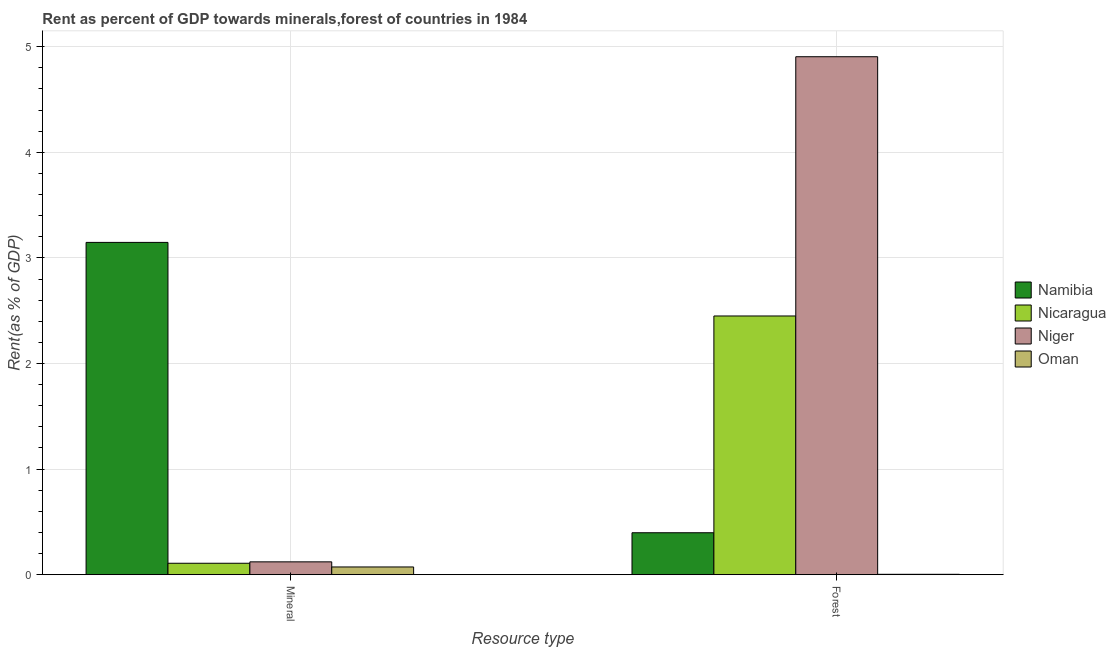How many groups of bars are there?
Offer a terse response. 2. How many bars are there on the 2nd tick from the left?
Offer a very short reply. 4. What is the label of the 2nd group of bars from the left?
Your answer should be very brief. Forest. What is the mineral rent in Namibia?
Your answer should be compact. 3.15. Across all countries, what is the maximum forest rent?
Offer a very short reply. 4.9. Across all countries, what is the minimum mineral rent?
Give a very brief answer. 0.07. In which country was the mineral rent maximum?
Provide a short and direct response. Namibia. In which country was the forest rent minimum?
Your answer should be very brief. Oman. What is the total forest rent in the graph?
Offer a very short reply. 7.76. What is the difference between the mineral rent in Oman and that in Nicaragua?
Provide a short and direct response. -0.04. What is the difference between the mineral rent in Niger and the forest rent in Namibia?
Offer a very short reply. -0.28. What is the average forest rent per country?
Offer a terse response. 1.94. What is the difference between the mineral rent and forest rent in Namibia?
Your answer should be compact. 2.75. What is the ratio of the mineral rent in Nicaragua to that in Niger?
Give a very brief answer. 0.89. Is the mineral rent in Nicaragua less than that in Oman?
Ensure brevity in your answer.  No. In how many countries, is the forest rent greater than the average forest rent taken over all countries?
Your answer should be compact. 2. What does the 3rd bar from the left in Mineral represents?
Give a very brief answer. Niger. What does the 3rd bar from the right in Forest represents?
Provide a succinct answer. Nicaragua. How many bars are there?
Your answer should be very brief. 8. Does the graph contain any zero values?
Your answer should be compact. No. Does the graph contain grids?
Keep it short and to the point. Yes. Where does the legend appear in the graph?
Keep it short and to the point. Center right. What is the title of the graph?
Provide a short and direct response. Rent as percent of GDP towards minerals,forest of countries in 1984. What is the label or title of the X-axis?
Make the answer very short. Resource type. What is the label or title of the Y-axis?
Offer a terse response. Rent(as % of GDP). What is the Rent(as % of GDP) in Namibia in Mineral?
Give a very brief answer. 3.15. What is the Rent(as % of GDP) in Nicaragua in Mineral?
Offer a very short reply. 0.11. What is the Rent(as % of GDP) of Niger in Mineral?
Your answer should be very brief. 0.12. What is the Rent(as % of GDP) in Oman in Mineral?
Offer a very short reply. 0.07. What is the Rent(as % of GDP) in Namibia in Forest?
Make the answer very short. 0.4. What is the Rent(as % of GDP) of Nicaragua in Forest?
Give a very brief answer. 2.45. What is the Rent(as % of GDP) in Niger in Forest?
Your response must be concise. 4.9. What is the Rent(as % of GDP) of Oman in Forest?
Provide a short and direct response. 0. Across all Resource type, what is the maximum Rent(as % of GDP) in Namibia?
Offer a very short reply. 3.15. Across all Resource type, what is the maximum Rent(as % of GDP) in Nicaragua?
Offer a terse response. 2.45. Across all Resource type, what is the maximum Rent(as % of GDP) of Niger?
Make the answer very short. 4.9. Across all Resource type, what is the maximum Rent(as % of GDP) of Oman?
Give a very brief answer. 0.07. Across all Resource type, what is the minimum Rent(as % of GDP) of Namibia?
Offer a very short reply. 0.4. Across all Resource type, what is the minimum Rent(as % of GDP) of Nicaragua?
Make the answer very short. 0.11. Across all Resource type, what is the minimum Rent(as % of GDP) of Niger?
Your answer should be compact. 0.12. Across all Resource type, what is the minimum Rent(as % of GDP) in Oman?
Your response must be concise. 0. What is the total Rent(as % of GDP) of Namibia in the graph?
Offer a terse response. 3.54. What is the total Rent(as % of GDP) of Nicaragua in the graph?
Your answer should be very brief. 2.56. What is the total Rent(as % of GDP) of Niger in the graph?
Give a very brief answer. 5.03. What is the total Rent(as % of GDP) of Oman in the graph?
Give a very brief answer. 0.08. What is the difference between the Rent(as % of GDP) of Namibia in Mineral and that in Forest?
Ensure brevity in your answer.  2.75. What is the difference between the Rent(as % of GDP) in Nicaragua in Mineral and that in Forest?
Give a very brief answer. -2.34. What is the difference between the Rent(as % of GDP) of Niger in Mineral and that in Forest?
Your answer should be compact. -4.78. What is the difference between the Rent(as % of GDP) of Oman in Mineral and that in Forest?
Keep it short and to the point. 0.07. What is the difference between the Rent(as % of GDP) of Namibia in Mineral and the Rent(as % of GDP) of Nicaragua in Forest?
Make the answer very short. 0.7. What is the difference between the Rent(as % of GDP) in Namibia in Mineral and the Rent(as % of GDP) in Niger in Forest?
Provide a succinct answer. -1.76. What is the difference between the Rent(as % of GDP) in Namibia in Mineral and the Rent(as % of GDP) in Oman in Forest?
Make the answer very short. 3.14. What is the difference between the Rent(as % of GDP) in Nicaragua in Mineral and the Rent(as % of GDP) in Niger in Forest?
Your answer should be compact. -4.8. What is the difference between the Rent(as % of GDP) of Nicaragua in Mineral and the Rent(as % of GDP) of Oman in Forest?
Provide a short and direct response. 0.1. What is the difference between the Rent(as % of GDP) of Niger in Mineral and the Rent(as % of GDP) of Oman in Forest?
Your answer should be very brief. 0.12. What is the average Rent(as % of GDP) in Namibia per Resource type?
Offer a very short reply. 1.77. What is the average Rent(as % of GDP) in Nicaragua per Resource type?
Your answer should be very brief. 1.28. What is the average Rent(as % of GDP) in Niger per Resource type?
Keep it short and to the point. 2.51. What is the average Rent(as % of GDP) of Oman per Resource type?
Your answer should be very brief. 0.04. What is the difference between the Rent(as % of GDP) in Namibia and Rent(as % of GDP) in Nicaragua in Mineral?
Ensure brevity in your answer.  3.04. What is the difference between the Rent(as % of GDP) in Namibia and Rent(as % of GDP) in Niger in Mineral?
Your answer should be very brief. 3.03. What is the difference between the Rent(as % of GDP) in Namibia and Rent(as % of GDP) in Oman in Mineral?
Your response must be concise. 3.07. What is the difference between the Rent(as % of GDP) in Nicaragua and Rent(as % of GDP) in Niger in Mineral?
Give a very brief answer. -0.01. What is the difference between the Rent(as % of GDP) in Nicaragua and Rent(as % of GDP) in Oman in Mineral?
Provide a succinct answer. 0.04. What is the difference between the Rent(as % of GDP) of Niger and Rent(as % of GDP) of Oman in Mineral?
Give a very brief answer. 0.05. What is the difference between the Rent(as % of GDP) in Namibia and Rent(as % of GDP) in Nicaragua in Forest?
Provide a succinct answer. -2.05. What is the difference between the Rent(as % of GDP) in Namibia and Rent(as % of GDP) in Niger in Forest?
Your answer should be very brief. -4.51. What is the difference between the Rent(as % of GDP) of Namibia and Rent(as % of GDP) of Oman in Forest?
Your response must be concise. 0.39. What is the difference between the Rent(as % of GDP) of Nicaragua and Rent(as % of GDP) of Niger in Forest?
Offer a very short reply. -2.45. What is the difference between the Rent(as % of GDP) of Nicaragua and Rent(as % of GDP) of Oman in Forest?
Provide a succinct answer. 2.45. What is the difference between the Rent(as % of GDP) in Niger and Rent(as % of GDP) in Oman in Forest?
Make the answer very short. 4.9. What is the ratio of the Rent(as % of GDP) in Namibia in Mineral to that in Forest?
Your answer should be very brief. 7.92. What is the ratio of the Rent(as % of GDP) in Nicaragua in Mineral to that in Forest?
Your response must be concise. 0.04. What is the ratio of the Rent(as % of GDP) in Niger in Mineral to that in Forest?
Your answer should be very brief. 0.02. What is the ratio of the Rent(as % of GDP) in Oman in Mineral to that in Forest?
Your response must be concise. 20.46. What is the difference between the highest and the second highest Rent(as % of GDP) of Namibia?
Your response must be concise. 2.75. What is the difference between the highest and the second highest Rent(as % of GDP) in Nicaragua?
Provide a short and direct response. 2.34. What is the difference between the highest and the second highest Rent(as % of GDP) in Niger?
Provide a succinct answer. 4.78. What is the difference between the highest and the second highest Rent(as % of GDP) of Oman?
Offer a terse response. 0.07. What is the difference between the highest and the lowest Rent(as % of GDP) of Namibia?
Make the answer very short. 2.75. What is the difference between the highest and the lowest Rent(as % of GDP) in Nicaragua?
Your answer should be compact. 2.34. What is the difference between the highest and the lowest Rent(as % of GDP) in Niger?
Keep it short and to the point. 4.78. What is the difference between the highest and the lowest Rent(as % of GDP) in Oman?
Your answer should be compact. 0.07. 